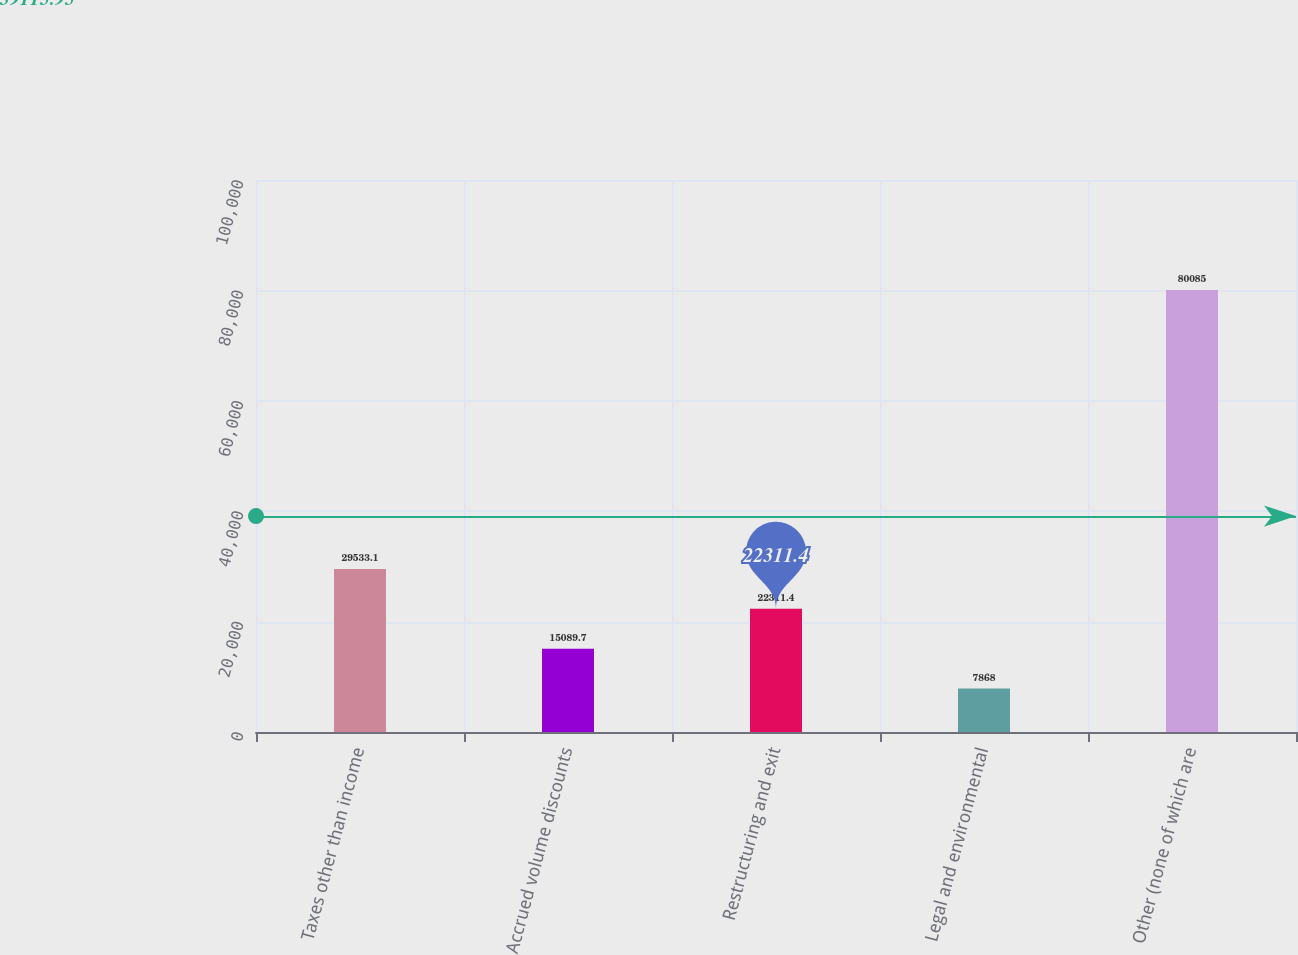Convert chart to OTSL. <chart><loc_0><loc_0><loc_500><loc_500><bar_chart><fcel>Taxes other than income<fcel>Accrued volume discounts<fcel>Restructuring and exit<fcel>Legal and environmental<fcel>Other (none of which are<nl><fcel>29533.1<fcel>15089.7<fcel>22311.4<fcel>7868<fcel>80085<nl></chart> 